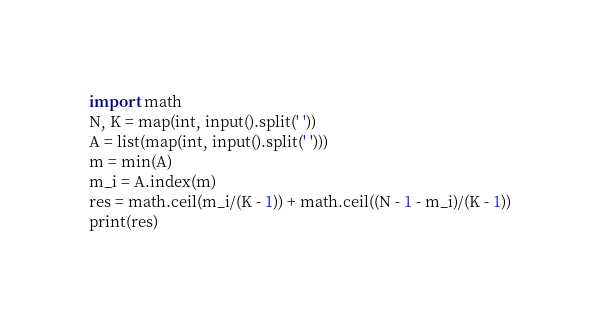<code> <loc_0><loc_0><loc_500><loc_500><_Python_>import math
N, K = map(int, input().split(' '))
A = list(map(int, input().split(' ')))
m = min(A)
m_i = A.index(m)
res = math.ceil(m_i/(K - 1)) + math.ceil((N - 1 - m_i)/(K - 1))
print(res)</code> 